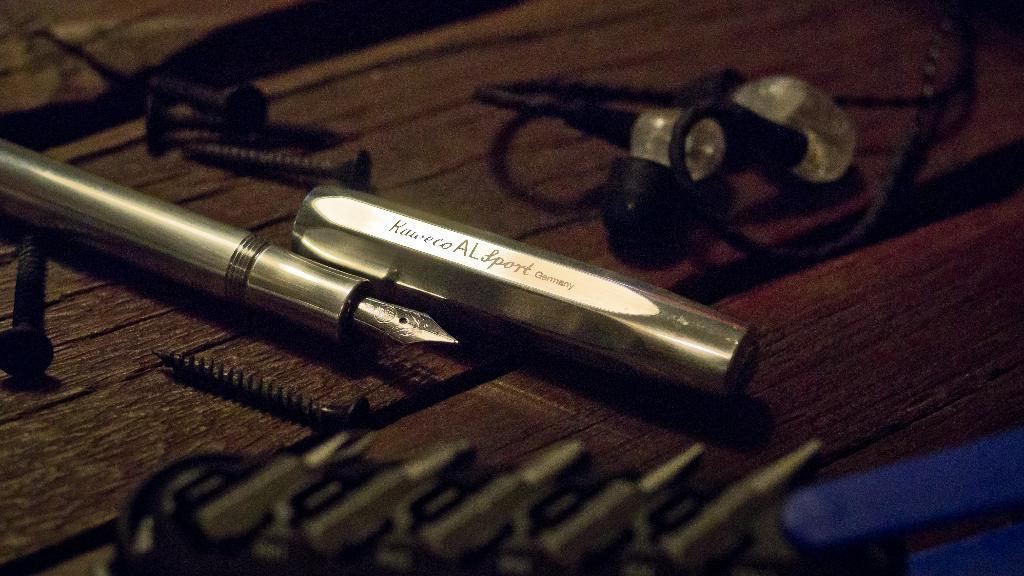What is one of the items visible in the image? There is a pen in the image. What else can be seen in the image besides the pen? There are screws and other objects in the image. Where are these items placed? All the items are placed on a wooden platform. Can you see any deer in the image? No, there are no deer present in the image. What type of vacation is being depicted in the image? The image does not depict a vacation; it shows a collection of items placed on a wooden platform. 